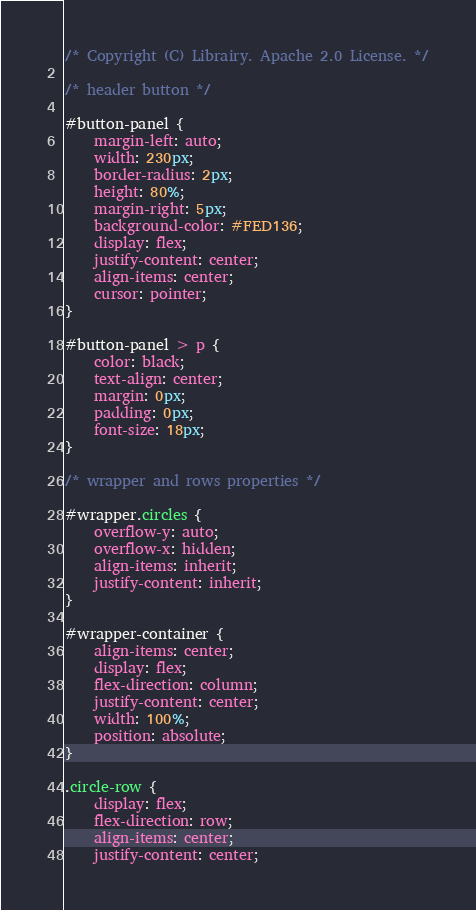Convert code to text. <code><loc_0><loc_0><loc_500><loc_500><_CSS_>/* Copyright (C) Librairy. Apache 2.0 License. */

/* header button */

#button-panel {
    margin-left: auto;
    width: 230px;
    border-radius: 2px;
    height: 80%;
    margin-right: 5px;
    background-color: #FED136;
    display: flex;
    justify-content: center;
    align-items: center;
    cursor: pointer;
}

#button-panel > p {
    color: black;
    text-align: center;
    margin: 0px;
    padding: 0px;
    font-size: 18px;
}

/* wrapper and rows properties */

#wrapper.circles {
    overflow-y: auto;
    overflow-x: hidden;
    align-items: inherit;
    justify-content: inherit;
}

#wrapper-container {
    align-items: center;
    display: flex;
    flex-direction: column;
    justify-content: center;
    width: 100%;
    position: absolute;
}

.circle-row {
    display: flex;
    flex-direction: row;
    align-items: center;
    justify-content: center;</code> 